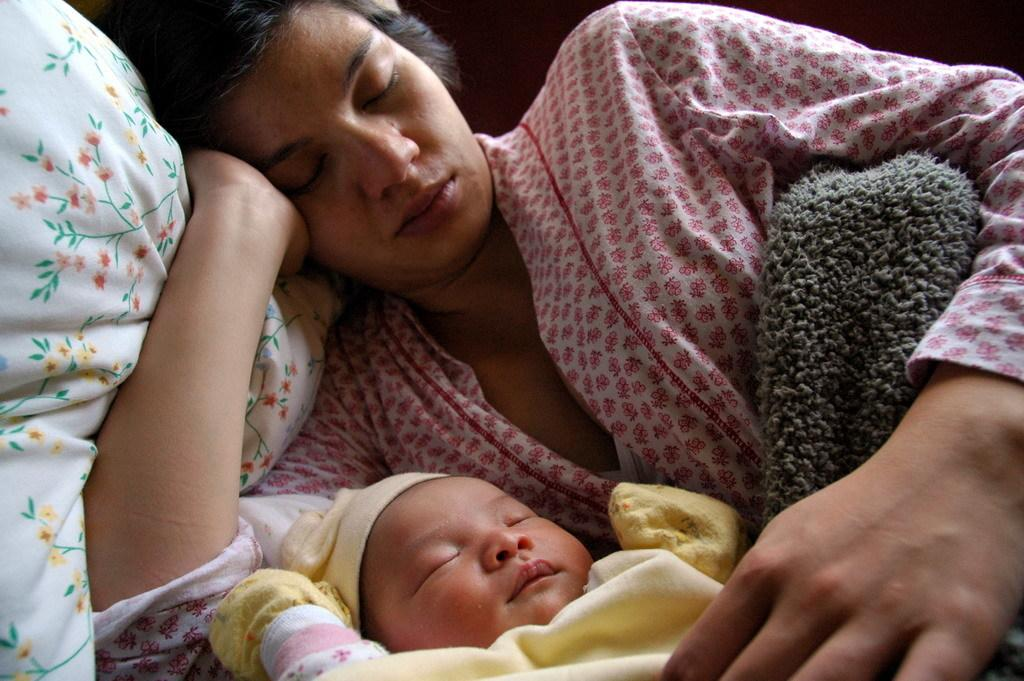What is the lady doing in the image? The lady is sleeping on a pillow in the image. What is covering the lady in the image? The lady has a blanket on her. What is the baby doing in the image? The baby is sleeping near the lady in the image. What accessories is the baby wearing in the image? The baby is wearing gloves and a cap in the image. What type of box is being used to promote peace in the image? There is no box or reference to promoting peace in the image. 